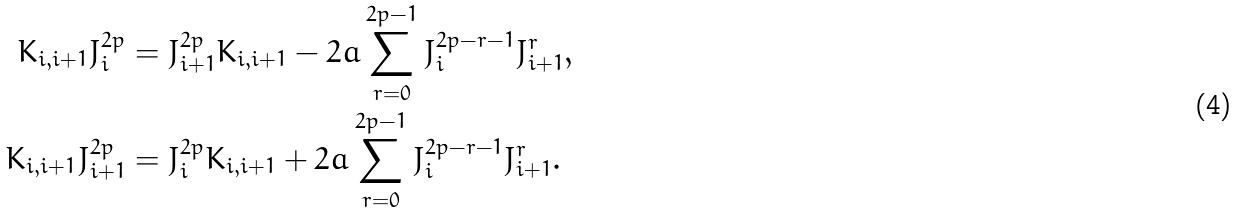<formula> <loc_0><loc_0><loc_500><loc_500>K _ { i , i + 1 } J _ { i } ^ { 2 p } & = J ^ { 2 p } _ { i + 1 } K _ { i , i + 1 } - 2 a \sum _ { r = 0 } ^ { 2 p - 1 } J _ { i } ^ { 2 p - r - 1 } J ^ { r } _ { i + 1 } , \\ K _ { i , i + 1 } J ^ { 2 p } _ { i + 1 } & = J _ { i } ^ { 2 p } K _ { i , i + 1 } + 2 a \sum _ { r = 0 } ^ { 2 p - 1 } J _ { i } ^ { 2 p - r - 1 } J ^ { r } _ { i + 1 } .</formula> 